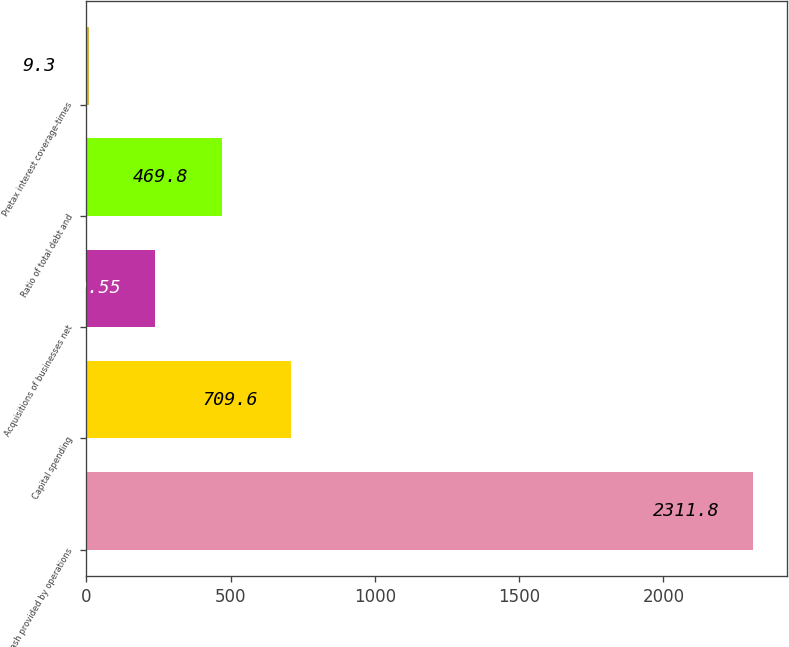<chart> <loc_0><loc_0><loc_500><loc_500><bar_chart><fcel>Cash provided by operations<fcel>Capital spending<fcel>Acquisitions of businesses net<fcel>Ratio of total debt and<fcel>Pretax interest coverage-times<nl><fcel>2311.8<fcel>709.6<fcel>239.55<fcel>469.8<fcel>9.3<nl></chart> 